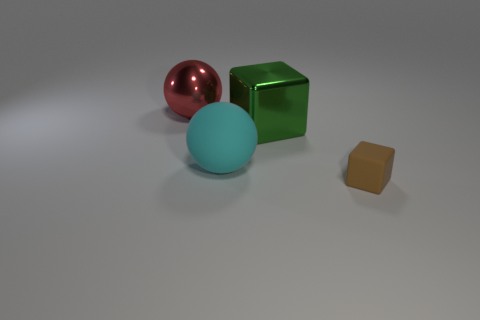Add 2 red things. How many objects exist? 6 Subtract all green blocks. How many blocks are left? 1 Subtract all large cyan rubber cylinders. Subtract all big red spheres. How many objects are left? 3 Add 1 shiny blocks. How many shiny blocks are left? 2 Add 4 red objects. How many red objects exist? 5 Subtract 0 gray cylinders. How many objects are left? 4 Subtract 1 balls. How many balls are left? 1 Subtract all brown spheres. Subtract all green cylinders. How many spheres are left? 2 